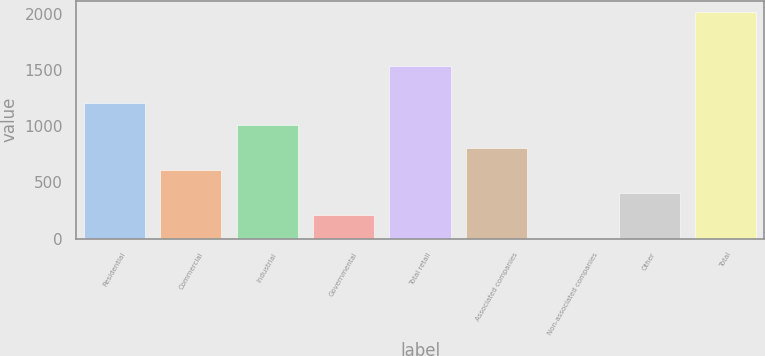Convert chart to OTSL. <chart><loc_0><loc_0><loc_500><loc_500><bar_chart><fcel>Residential<fcel>Commercial<fcel>Industrial<fcel>Governmental<fcel>Total retail<fcel>Associated companies<fcel>Non-associated companies<fcel>Other<fcel>Total<nl><fcel>1209.6<fcel>607.8<fcel>1009<fcel>206.6<fcel>1539<fcel>808.4<fcel>6<fcel>407.2<fcel>2012<nl></chart> 